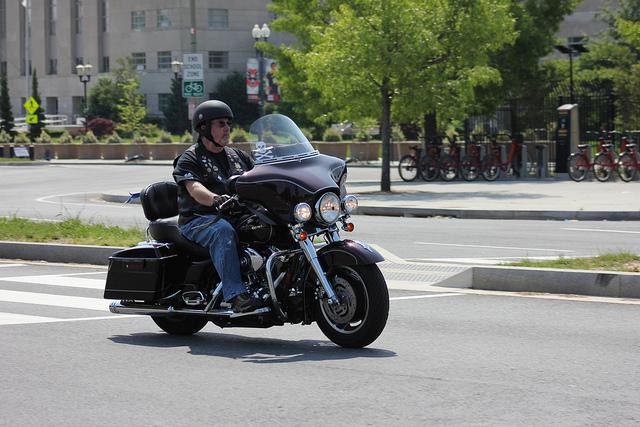Is this person in a race?
Write a very short answer. No. Is this man on the street?
Give a very brief answer. Yes. Does the rider enjoy riding motorcycles?
Concise answer only. Yes. Is the rider wearing a helmet?
Write a very short answer. Yes. 